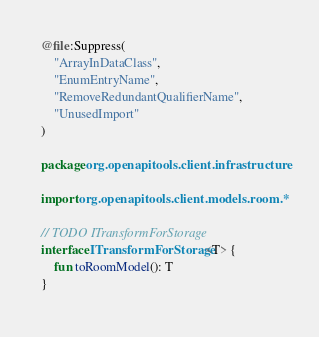<code> <loc_0><loc_0><loc_500><loc_500><_Kotlin_>
@file:Suppress(
    "ArrayInDataClass",
    "EnumEntryName",
    "RemoveRedundantQualifierName",
    "UnusedImport"
)

package org.openapitools.client.infrastructure

import org.openapitools.client.models.room.*

// TODO ITransformForStorage
interface ITransformForStorage<T> {
    fun toRoomModel(): T
}</code> 